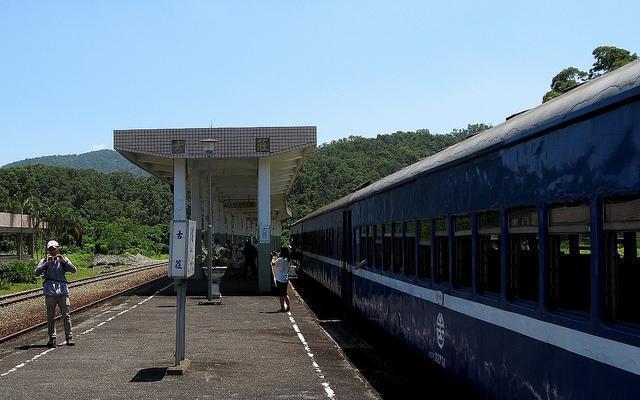Who is sheltered here?
From the following four choices, select the correct answer to address the question.
Options: No one, train riders, bus riders, mall walkers. Train riders. 